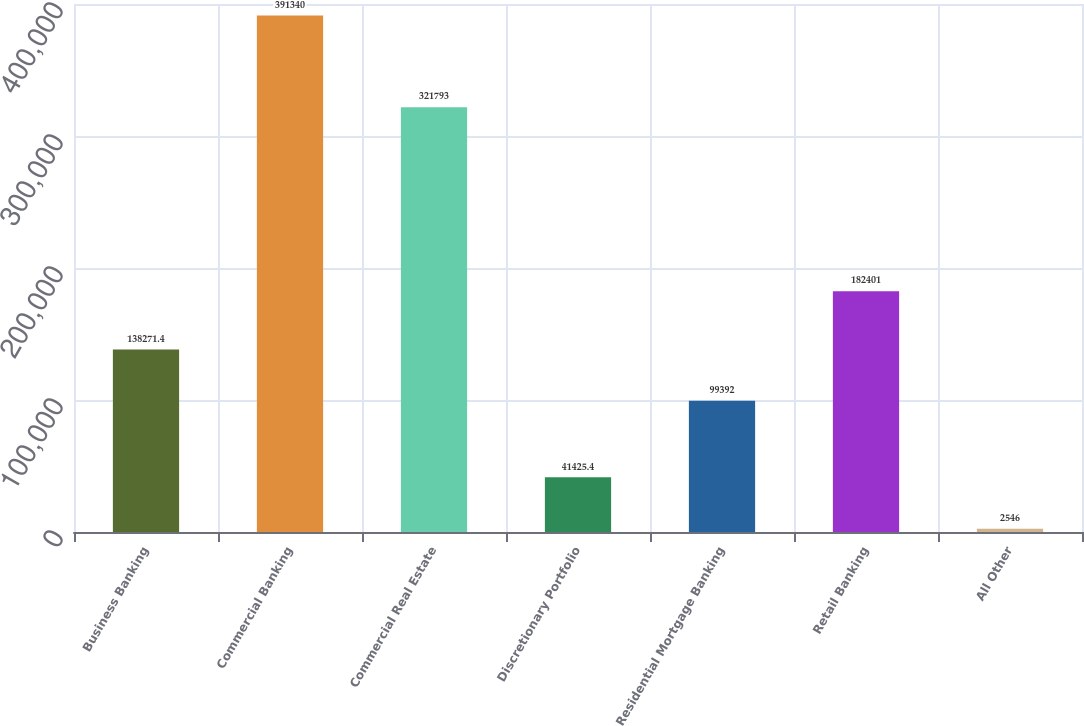<chart> <loc_0><loc_0><loc_500><loc_500><bar_chart><fcel>Business Banking<fcel>Commercial Banking<fcel>Commercial Real Estate<fcel>Discretionary Portfolio<fcel>Residential Mortgage Banking<fcel>Retail Banking<fcel>All Other<nl><fcel>138271<fcel>391340<fcel>321793<fcel>41425.4<fcel>99392<fcel>182401<fcel>2546<nl></chart> 